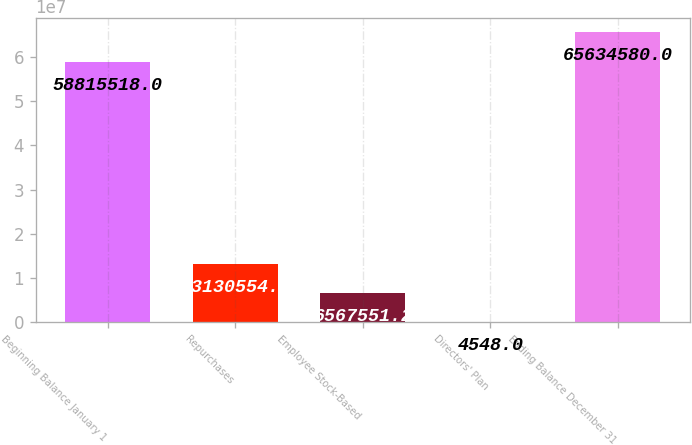Convert chart. <chart><loc_0><loc_0><loc_500><loc_500><bar_chart><fcel>Beginning Balance January 1<fcel>Repurchases<fcel>Employee Stock-Based<fcel>Directors' Plan<fcel>Ending Balance December 31<nl><fcel>5.88155e+07<fcel>1.31306e+07<fcel>6.56755e+06<fcel>4548<fcel>6.56346e+07<nl></chart> 